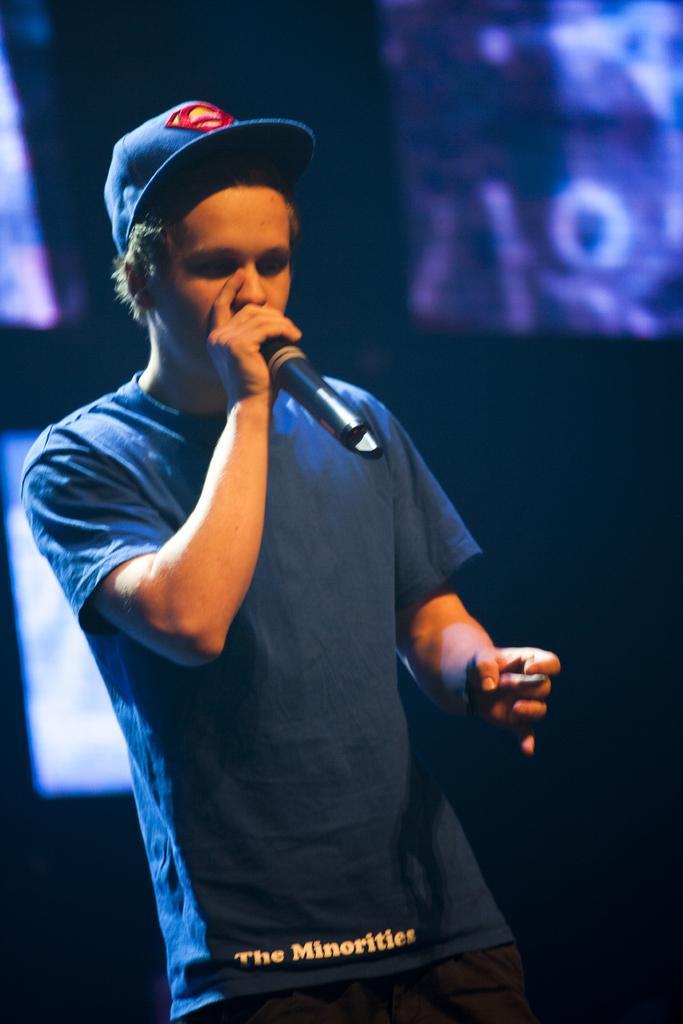How would you summarize this image in a sentence or two? As we can see in the image there is a man wearing blue color t shirt, cap and holding a mic. In the background there are screens and the image is little dark. 